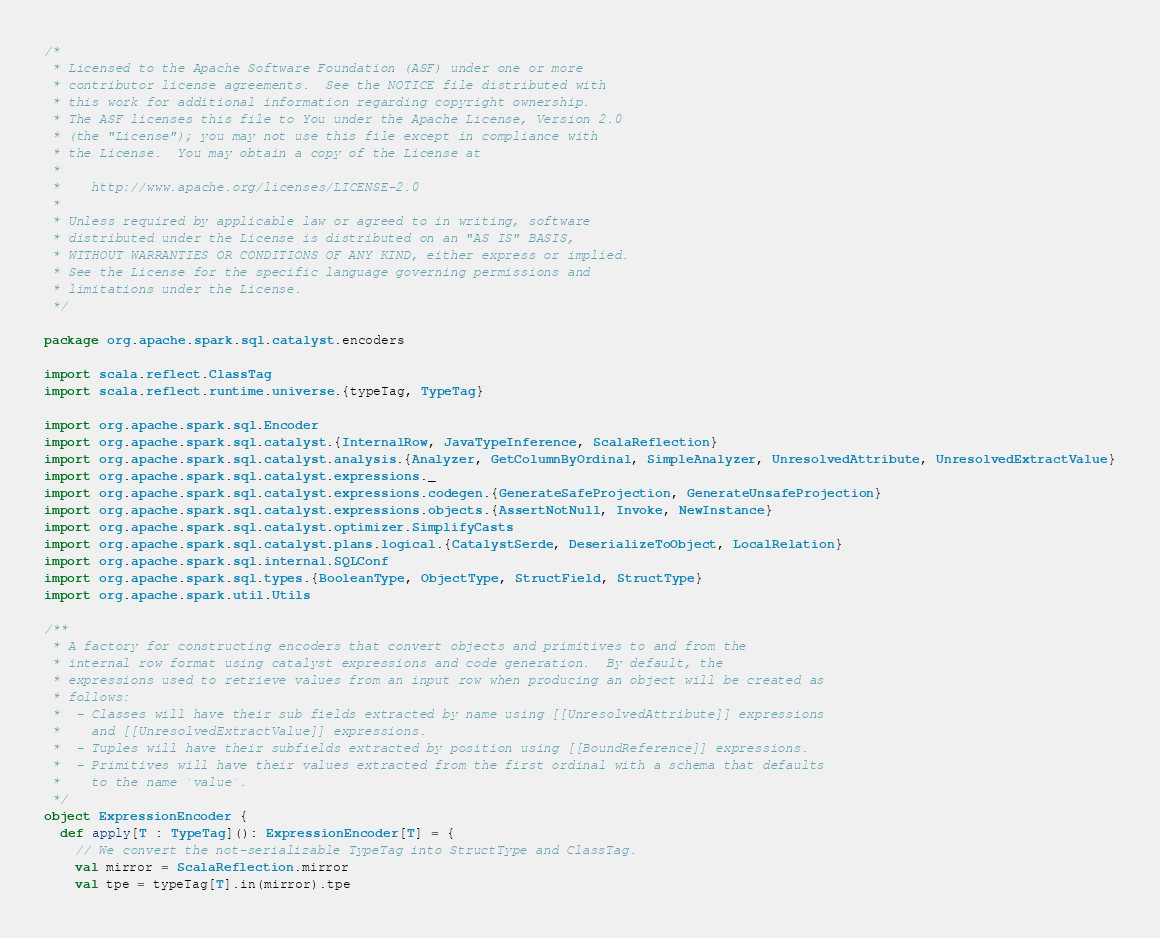<code> <loc_0><loc_0><loc_500><loc_500><_Scala_>/*
 * Licensed to the Apache Software Foundation (ASF) under one or more
 * contributor license agreements.  See the NOTICE file distributed with
 * this work for additional information regarding copyright ownership.
 * The ASF licenses this file to You under the Apache License, Version 2.0
 * (the "License"); you may not use this file except in compliance with
 * the License.  You may obtain a copy of the License at
 *
 *    http://www.apache.org/licenses/LICENSE-2.0
 *
 * Unless required by applicable law or agreed to in writing, software
 * distributed under the License is distributed on an "AS IS" BASIS,
 * WITHOUT WARRANTIES OR CONDITIONS OF ANY KIND, either express or implied.
 * See the License for the specific language governing permissions and
 * limitations under the License.
 */

package org.apache.spark.sql.catalyst.encoders

import scala.reflect.ClassTag
import scala.reflect.runtime.universe.{typeTag, TypeTag}

import org.apache.spark.sql.Encoder
import org.apache.spark.sql.catalyst.{InternalRow, JavaTypeInference, ScalaReflection}
import org.apache.spark.sql.catalyst.analysis.{Analyzer, GetColumnByOrdinal, SimpleAnalyzer, UnresolvedAttribute, UnresolvedExtractValue}
import org.apache.spark.sql.catalyst.expressions._
import org.apache.spark.sql.catalyst.expressions.codegen.{GenerateSafeProjection, GenerateUnsafeProjection}
import org.apache.spark.sql.catalyst.expressions.objects.{AssertNotNull, Invoke, NewInstance}
import org.apache.spark.sql.catalyst.optimizer.SimplifyCasts
import org.apache.spark.sql.catalyst.plans.logical.{CatalystSerde, DeserializeToObject, LocalRelation}
import org.apache.spark.sql.internal.SQLConf
import org.apache.spark.sql.types.{BooleanType, ObjectType, StructField, StructType}
import org.apache.spark.util.Utils

/**
 * A factory for constructing encoders that convert objects and primitives to and from the
 * internal row format using catalyst expressions and code generation.  By default, the
 * expressions used to retrieve values from an input row when producing an object will be created as
 * follows:
 *  - Classes will have their sub fields extracted by name using [[UnresolvedAttribute]] expressions
 *    and [[UnresolvedExtractValue]] expressions.
 *  - Tuples will have their subfields extracted by position using [[BoundReference]] expressions.
 *  - Primitives will have their values extracted from the first ordinal with a schema that defaults
 *    to the name `value`.
 */
object ExpressionEncoder {
  def apply[T : TypeTag](): ExpressionEncoder[T] = {
    // We convert the not-serializable TypeTag into StructType and ClassTag.
    val mirror = ScalaReflection.mirror
    val tpe = typeTag[T].in(mirror).tpe
</code> 